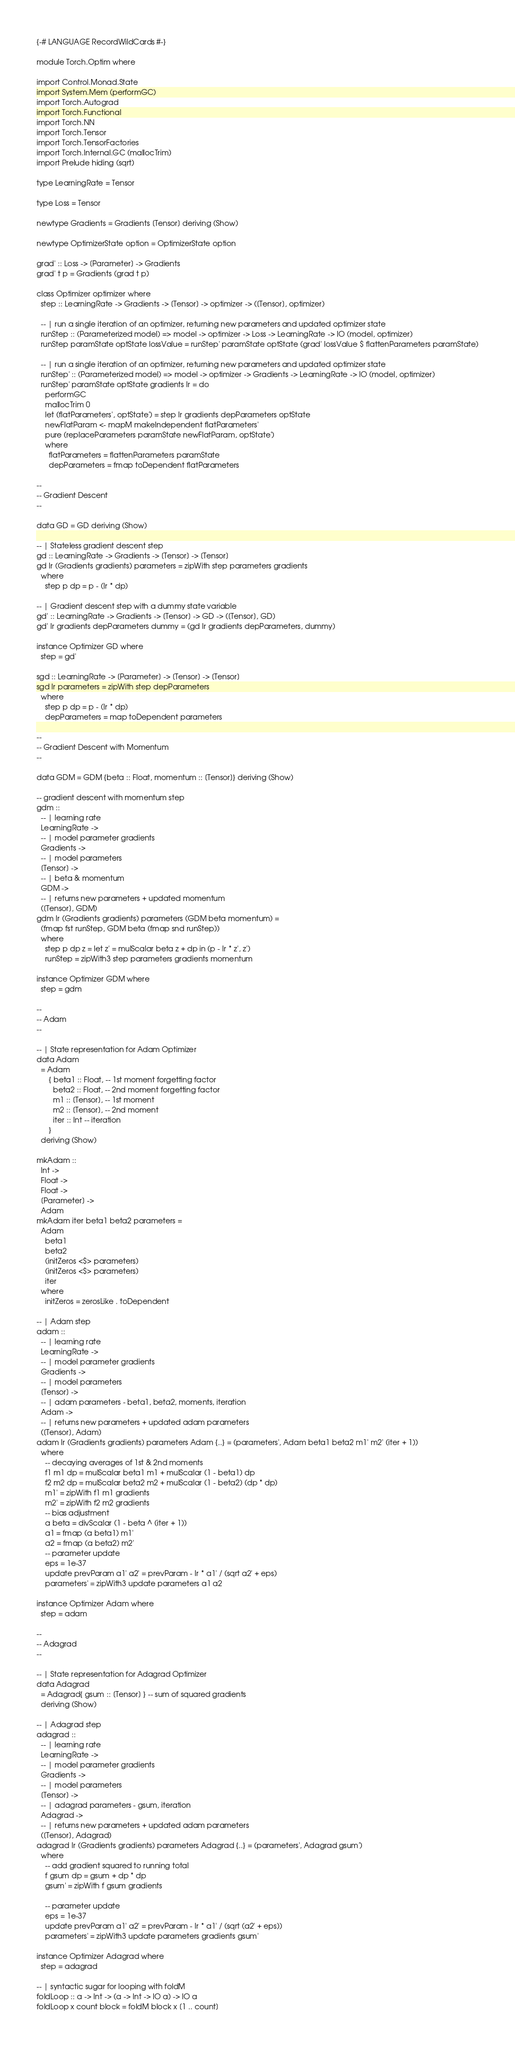<code> <loc_0><loc_0><loc_500><loc_500><_Haskell_>{-# LANGUAGE RecordWildCards #-}

module Torch.Optim where

import Control.Monad.State
import System.Mem (performGC)
import Torch.Autograd
import Torch.Functional
import Torch.NN
import Torch.Tensor
import Torch.TensorFactories
import Torch.Internal.GC (mallocTrim)
import Prelude hiding (sqrt)

type LearningRate = Tensor

type Loss = Tensor

newtype Gradients = Gradients [Tensor] deriving (Show)

newtype OptimizerState option = OptimizerState option

grad' :: Loss -> [Parameter] -> Gradients
grad' t p = Gradients (grad t p)

class Optimizer optimizer where
  step :: LearningRate -> Gradients -> [Tensor] -> optimizer -> ([Tensor], optimizer)

  -- | run a single iteration of an optimizer, returning new parameters and updated optimizer state
  runStep :: (Parameterized model) => model -> optimizer -> Loss -> LearningRate -> IO (model, optimizer)
  runStep paramState optState lossValue = runStep' paramState optState (grad' lossValue $ flattenParameters paramState)

  -- | run a single iteration of an optimizer, returning new parameters and updated optimizer state
  runStep' :: (Parameterized model) => model -> optimizer -> Gradients -> LearningRate -> IO (model, optimizer)
  runStep' paramState optState gradients lr = do
    performGC
    mallocTrim 0
    let (flatParameters', optState') = step lr gradients depParameters optState
    newFlatParam <- mapM makeIndependent flatParameters'
    pure (replaceParameters paramState newFlatParam, optState')
    where
      flatParameters = flattenParameters paramState
      depParameters = fmap toDependent flatParameters

--
-- Gradient Descent
--

data GD = GD deriving (Show)

-- | Stateless gradient descent step
gd :: LearningRate -> Gradients -> [Tensor] -> [Tensor]
gd lr (Gradients gradients) parameters = zipWith step parameters gradients
  where
    step p dp = p - (lr * dp)

-- | Gradient descent step with a dummy state variable
gd' :: LearningRate -> Gradients -> [Tensor] -> GD -> ([Tensor], GD)
gd' lr gradients depParameters dummy = (gd lr gradients depParameters, dummy)

instance Optimizer GD where
  step = gd'

sgd :: LearningRate -> [Parameter] -> [Tensor] -> [Tensor]
sgd lr parameters = zipWith step depParameters
  where
    step p dp = p - (lr * dp)
    depParameters = map toDependent parameters

--
-- Gradient Descent with Momentum
--

data GDM = GDM {beta :: Float, momentum :: [Tensor]} deriving (Show)

-- gradient descent with momentum step
gdm ::
  -- | learning rate
  LearningRate ->
  -- | model parameter gradients
  Gradients ->
  -- | model parameters
  [Tensor] ->
  -- | beta & momentum
  GDM ->
  -- | returns new parameters + updated momentum
  ([Tensor], GDM)
gdm lr (Gradients gradients) parameters (GDM beta momentum) =
  (fmap fst runStep, GDM beta (fmap snd runStep))
  where
    step p dp z = let z' = mulScalar beta z + dp in (p - lr * z', z')
    runStep = zipWith3 step parameters gradients momentum

instance Optimizer GDM where
  step = gdm

--
-- Adam
--

-- | State representation for Adam Optimizer
data Adam
  = Adam
      { beta1 :: Float, -- 1st moment forgetting factor
        beta2 :: Float, -- 2nd moment forgetting factor
        m1 :: [Tensor], -- 1st moment
        m2 :: [Tensor], -- 2nd moment
        iter :: Int -- iteration
      }
  deriving (Show)

mkAdam ::
  Int ->
  Float ->
  Float ->
  [Parameter] ->
  Adam
mkAdam iter beta1 beta2 parameters =
  Adam
    beta1
    beta2
    (initZeros <$> parameters)
    (initZeros <$> parameters)
    iter
  where
    initZeros = zerosLike . toDependent

-- | Adam step
adam ::
  -- | learning rate
  LearningRate ->
  -- | model parameter gradients
  Gradients ->
  -- | model parameters
  [Tensor] ->
  -- | adam parameters - beta1, beta2, moments, iteration
  Adam ->
  -- | returns new parameters + updated adam parameters
  ([Tensor], Adam)
adam lr (Gradients gradients) parameters Adam {..} = (parameters', Adam beta1 beta2 m1' m2' (iter + 1))
  where
    -- decaying averages of 1st & 2nd moments
    f1 m1 dp = mulScalar beta1 m1 + mulScalar (1 - beta1) dp
    f2 m2 dp = mulScalar beta2 m2 + mulScalar (1 - beta2) (dp * dp)
    m1' = zipWith f1 m1 gradients
    m2' = zipWith f2 m2 gradients
    -- bias adjustment
    a beta = divScalar (1 - beta ^ (iter + 1))
    a1 = fmap (a beta1) m1'
    a2 = fmap (a beta2) m2'
    -- parameter update
    eps = 1e-37
    update prevParam a1' a2' = prevParam - lr * a1' / (sqrt a2' + eps)
    parameters' = zipWith3 update parameters a1 a2

instance Optimizer Adam where
  step = adam

--
-- Adagrad
--

-- | State representation for Adagrad Optimizer
data Adagrad
  = Adagrad{ gsum :: [Tensor] } -- sum of squared gradients
  deriving (Show)

-- | Adagrad step
adagrad ::
  -- | learning rate
  LearningRate ->
  -- | model parameter gradients
  Gradients ->
  -- | model parameters
  [Tensor] ->
  -- | adagrad parameters - gsum, iteration
  Adagrad ->
  -- | returns new parameters + updated adam parameters
  ([Tensor], Adagrad)
adagrad lr (Gradients gradients) parameters Adagrad {..} = (parameters', Adagrad gsum')
  where
    -- add gradient squared to running total
    f gsum dp = gsum + dp * dp
    gsum' = zipWith f gsum gradients

    -- parameter update
    eps = 1e-37
    update prevParam a1' a2' = prevParam - lr * a1' / (sqrt (a2' + eps))
    parameters' = zipWith3 update parameters gradients gsum'

instance Optimizer Adagrad where
  step = adagrad

-- | syntactic sugar for looping with foldM
foldLoop :: a -> Int -> (a -> Int -> IO a) -> IO a
foldLoop x count block = foldM block x [1 .. count]
</code> 